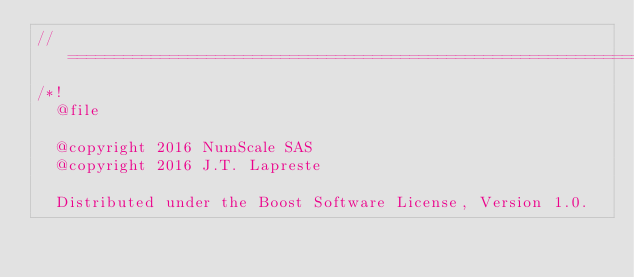Convert code to text. <code><loc_0><loc_0><loc_500><loc_500><_C++_>//==================================================================================================
/*!
  @file

  @copyright 2016 NumScale SAS
  @copyright 2016 J.T. Lapreste

  Distributed under the Boost Software License, Version 1.0.</code> 